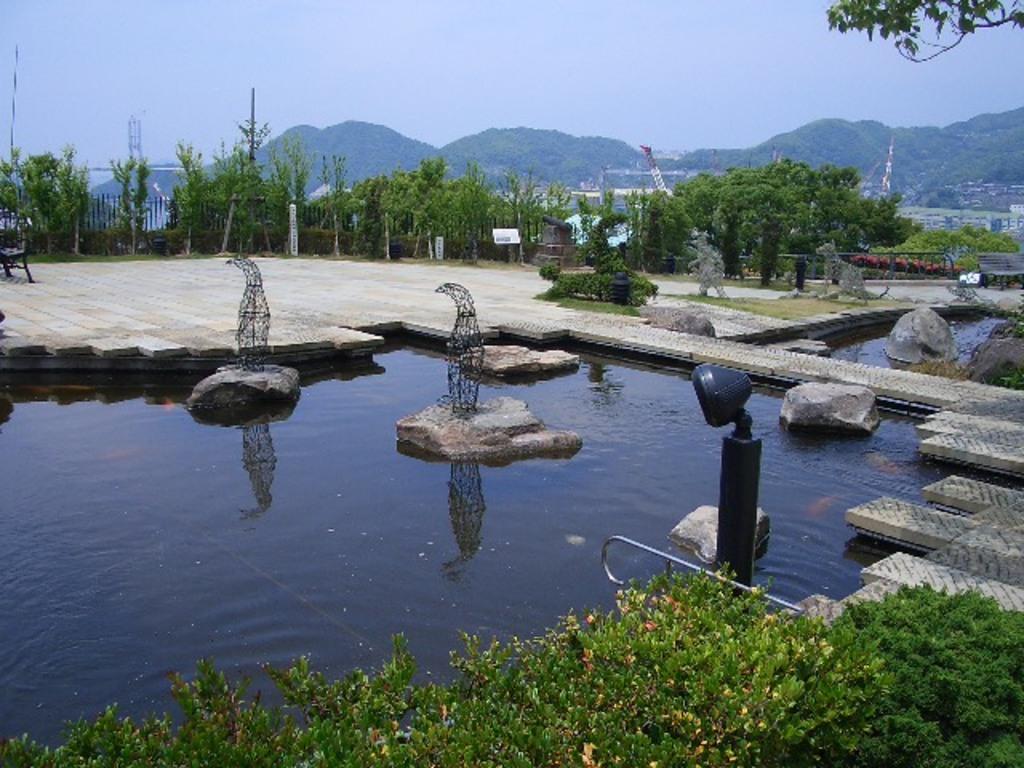Describe this image in one or two sentences. There is water and there are few rocks in between it and there are trees and buildings in the background. 